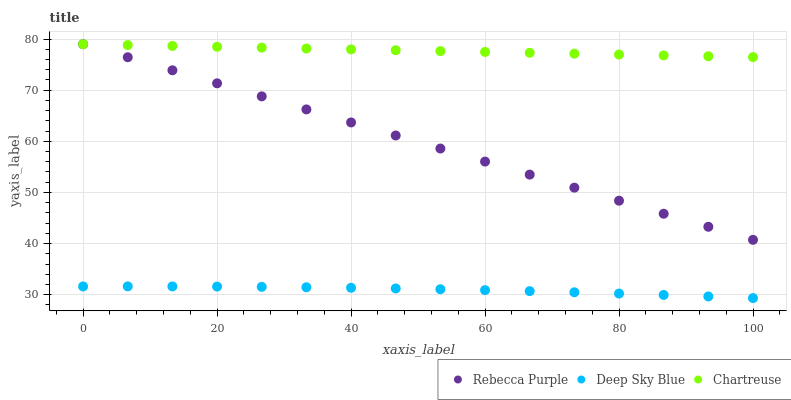Does Deep Sky Blue have the minimum area under the curve?
Answer yes or no. Yes. Does Chartreuse have the maximum area under the curve?
Answer yes or no. Yes. Does Rebecca Purple have the minimum area under the curve?
Answer yes or no. No. Does Rebecca Purple have the maximum area under the curve?
Answer yes or no. No. Is Rebecca Purple the smoothest?
Answer yes or no. Yes. Is Deep Sky Blue the roughest?
Answer yes or no. Yes. Is Deep Sky Blue the smoothest?
Answer yes or no. No. Is Rebecca Purple the roughest?
Answer yes or no. No. Does Deep Sky Blue have the lowest value?
Answer yes or no. Yes. Does Rebecca Purple have the lowest value?
Answer yes or no. No. Does Rebecca Purple have the highest value?
Answer yes or no. Yes. Does Deep Sky Blue have the highest value?
Answer yes or no. No. Is Deep Sky Blue less than Chartreuse?
Answer yes or no. Yes. Is Rebecca Purple greater than Deep Sky Blue?
Answer yes or no. Yes. Does Chartreuse intersect Rebecca Purple?
Answer yes or no. Yes. Is Chartreuse less than Rebecca Purple?
Answer yes or no. No. Is Chartreuse greater than Rebecca Purple?
Answer yes or no. No. Does Deep Sky Blue intersect Chartreuse?
Answer yes or no. No. 